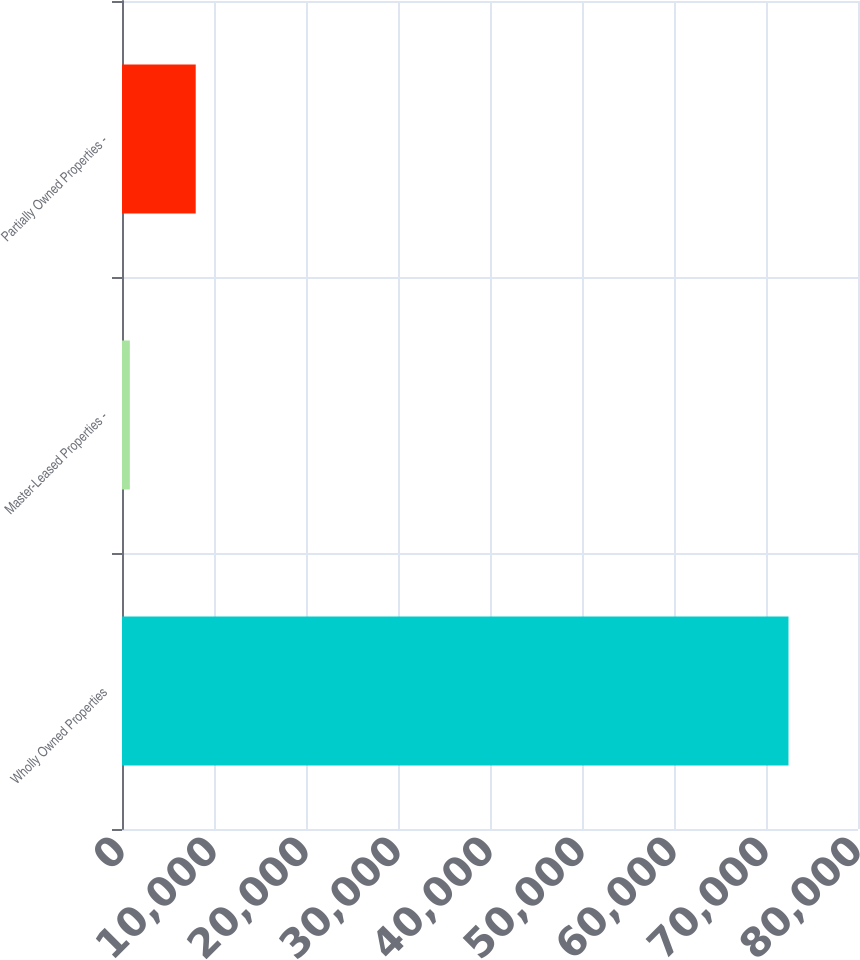Convert chart to OTSL. <chart><loc_0><loc_0><loc_500><loc_500><bar_chart><fcel>Wholly Owned Properties<fcel>Master-Leased Properties -<fcel>Partially Owned Properties -<nl><fcel>72445<fcel>853<fcel>8012.2<nl></chart> 